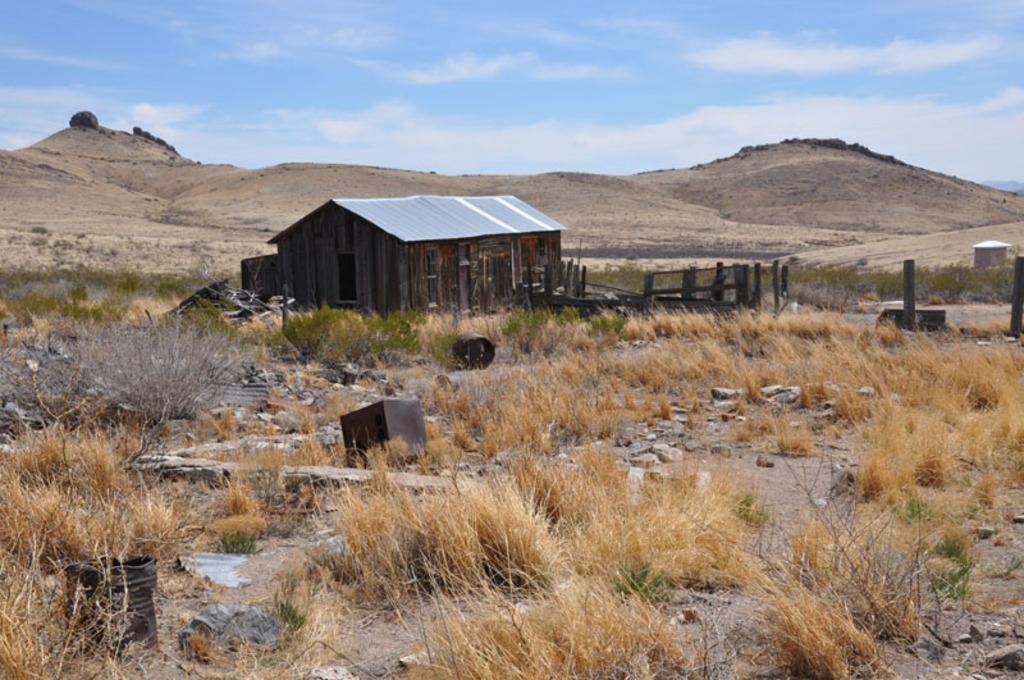How would you summarize this image in a sentence or two? In this picture we can see some grass on the path. There are a few black objects and some stones on the path. We can see a shed and poles. There is a house in the background. Sky is blue in color and cloudy. 